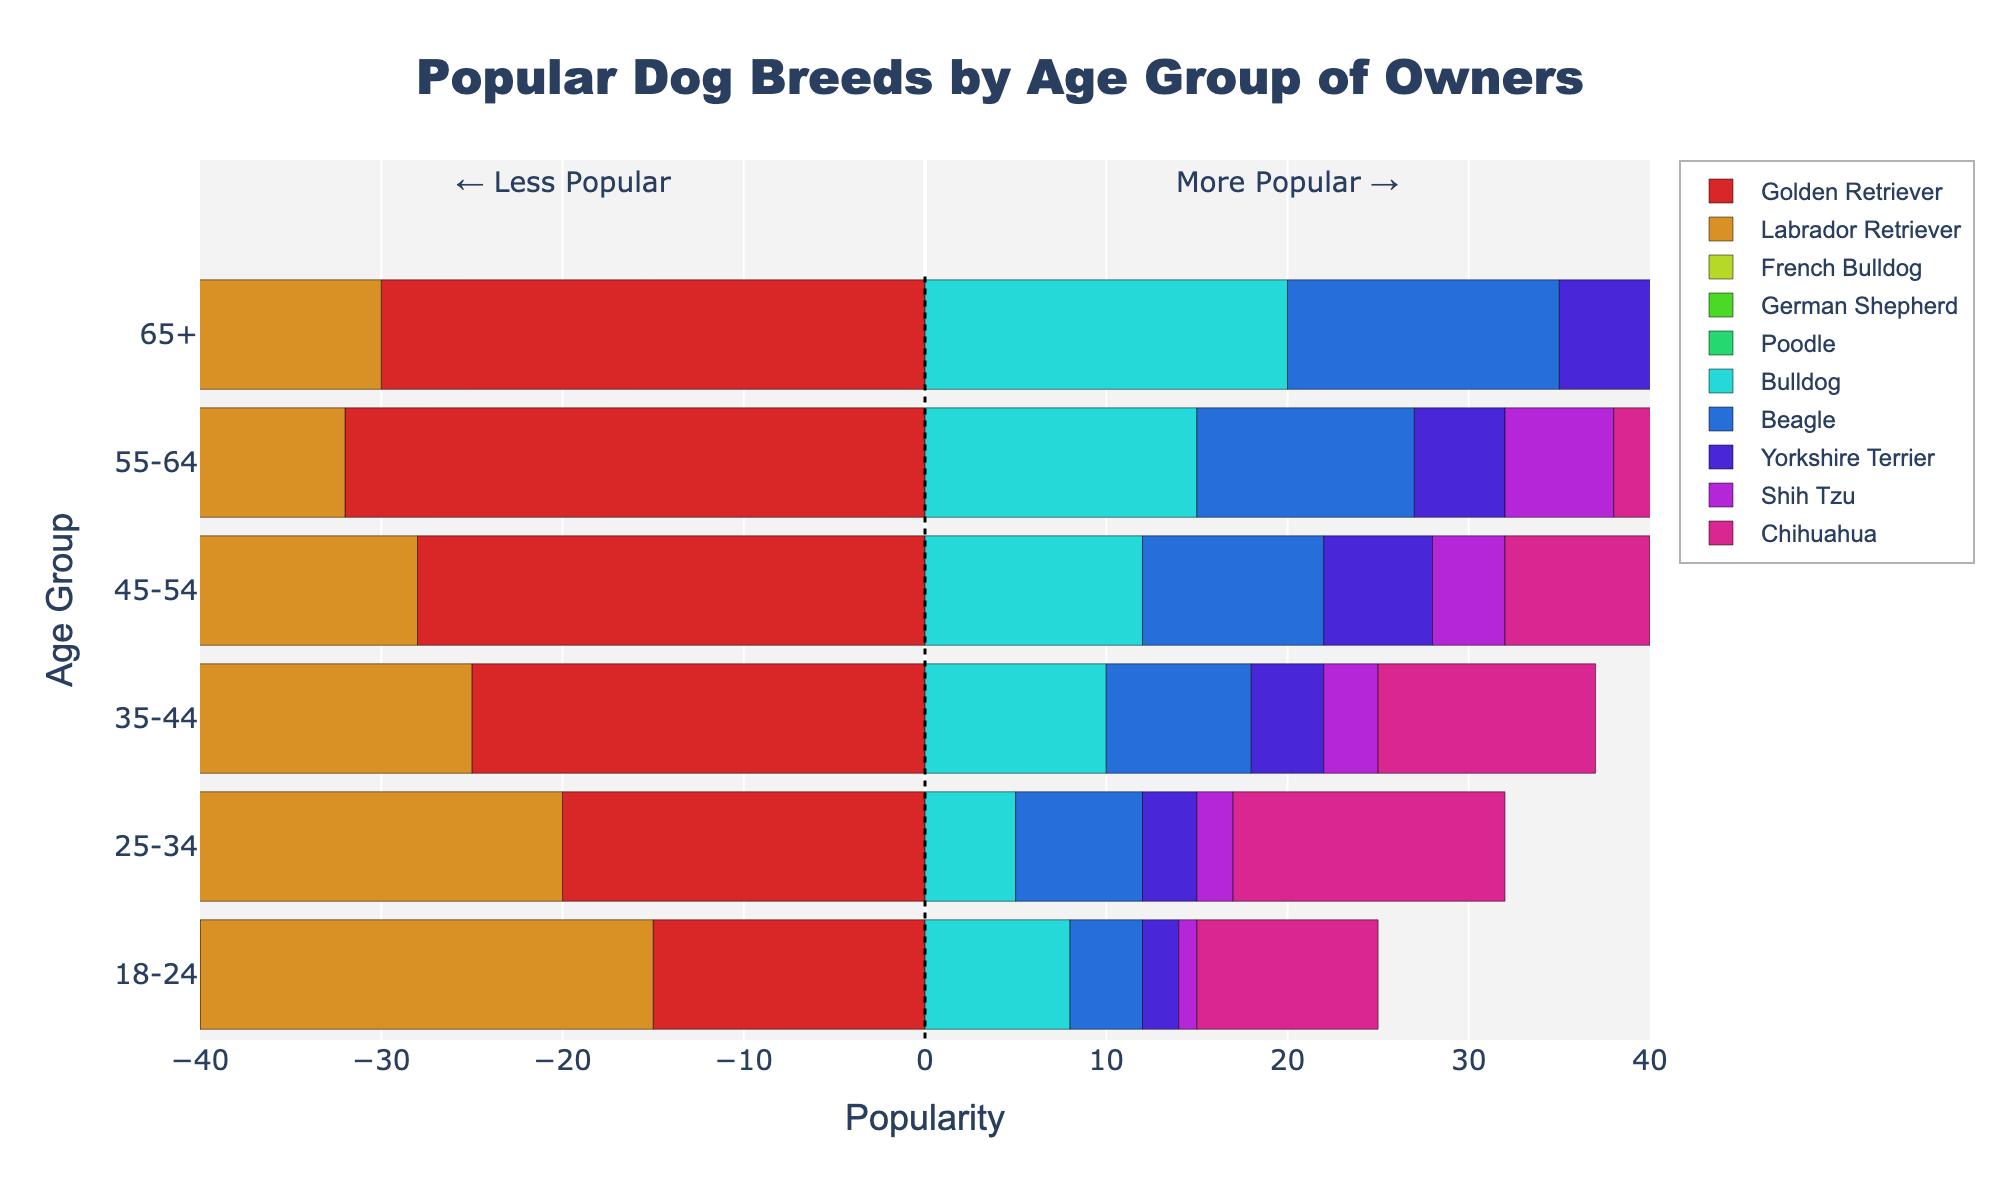What age group has the highest popularity for the Labrador Retriever? The bar representing the Labrador Retriever for the age group 35-44 is the longest, indicating this age group has the highest popularity for Labrador Retrievers
Answer: 35-44 Compare the popularity of the Golden Retriever between the 18-24 and 65+ age groups. The bar for Golden Retrievers in the 18-24 age group is negative and short, indicating lower popularity, while the bar in the 65+ age group is also short, but on the positive side, indicating more popularity in the 65+ age group.
Answer: 65+ popular than 18-24 Which dog breed has the broadest range of popularity across all age groups? By visually comparing the length of bars for each dog breed across all age groups, the breeds with the widest range of heights will stand out. The Labrador Retriever has relatively long bars for each age group, indicating a broad range of popularity.
Answer: Labrador Retriever What's the total popularity score for Bulldogs for all age groups combined? Add the bars’ lengths for Bulldogs from each age group: 18-24 (8), 25-34 (5), 35-44 (10), 45-54 (12), 55-64 (15), 65+ (20). Summing these up: 8 + 5 + 10 + 12 + 15 + 20 = 70.
Answer: 70 Which age group sees a higher popularity of German Shepherds: 35-44 or 45-54? By comparing the length of the bars for German Shepherds in the 35-44 and 45-54 age groups, the bar is slightly longer for the 45-54 age group.
Answer: 45-54 How does the popularity of French Bulldogs among 18-24-year-olds compare to their popularity among 55-64-year-olds? The bar for French Bulldogs in the 18-24 age group is long on the positive side, while the bar in the 55-64 age group is also on the positive side but shorter. This indicates French Bulldogs are more popular among 18-24-year-olds than 55-64-year-olds.
Answer: More popular among 18-24 Which dog breed among Beagle, Bulldog, and Shih Tzu is most popular among the 55-64 age group? By comparing the positive bars for Beagle, Bulldog, and Shih Tzu in the 55-64 age group, the Bulldog bar is the longest.
Answer: Bulldog What's the difference in popularity of Chihuahuas between the 25-34 and 65+ age groups? Subtract the Chihuahua bar length for the 65+ age group (3) from the Chihuahua bar length for the 25-34 age group (15). The difference is 15 - 3.
Answer: 12 Which age group prefers Poodles the most? The age group with the longest positive bar for Poodles is the 65+ age group.
Answer: 65+ For the 25-34 age group, which breed is more popular: Beagle or Yorkshire Terrier? Compare the lengths of the bars for Beagle and Yorkshire Terrier in the 25-34 age group; the Beagle bar is longer.
Answer: Beagle 